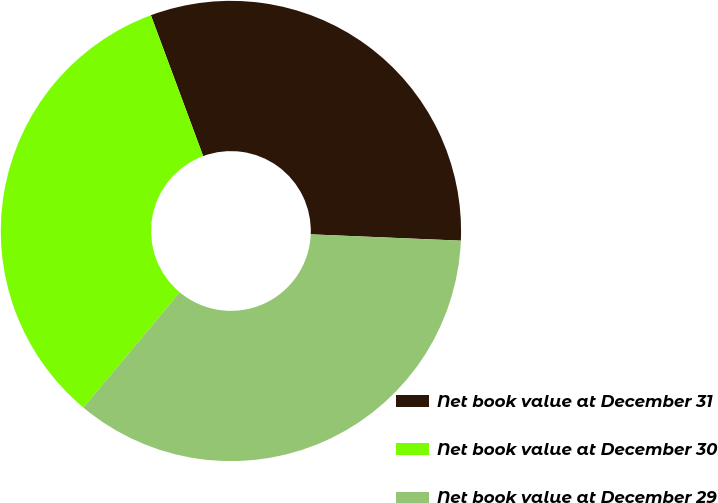Convert chart. <chart><loc_0><loc_0><loc_500><loc_500><pie_chart><fcel>Net book value at December 31<fcel>Net book value at December 30<fcel>Net book value at December 29<nl><fcel>31.32%<fcel>33.27%<fcel>35.4%<nl></chart> 